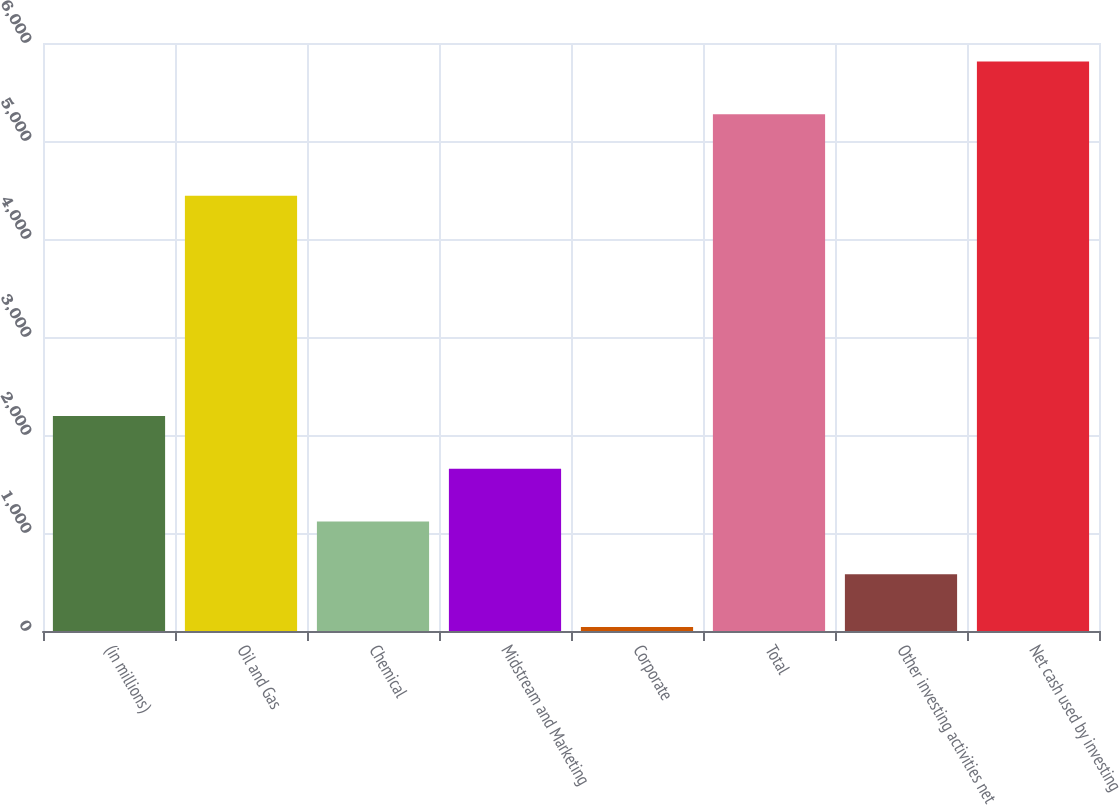<chart> <loc_0><loc_0><loc_500><loc_500><bar_chart><fcel>(in millions)<fcel>Oil and Gas<fcel>Chemical<fcel>Midstream and Marketing<fcel>Corporate<fcel>Total<fcel>Other investing activities net<fcel>Net cash used by investing<nl><fcel>2193.8<fcel>4442<fcel>1117.4<fcel>1655.6<fcel>41<fcel>5272<fcel>579.2<fcel>5810.2<nl></chart> 